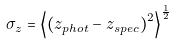<formula> <loc_0><loc_0><loc_500><loc_500>\sigma _ { z } = \left < \left ( z _ { p h o t } - z _ { s p e c } \right ) ^ { 2 } \right > ^ { \frac { 1 } { 2 } }</formula> 